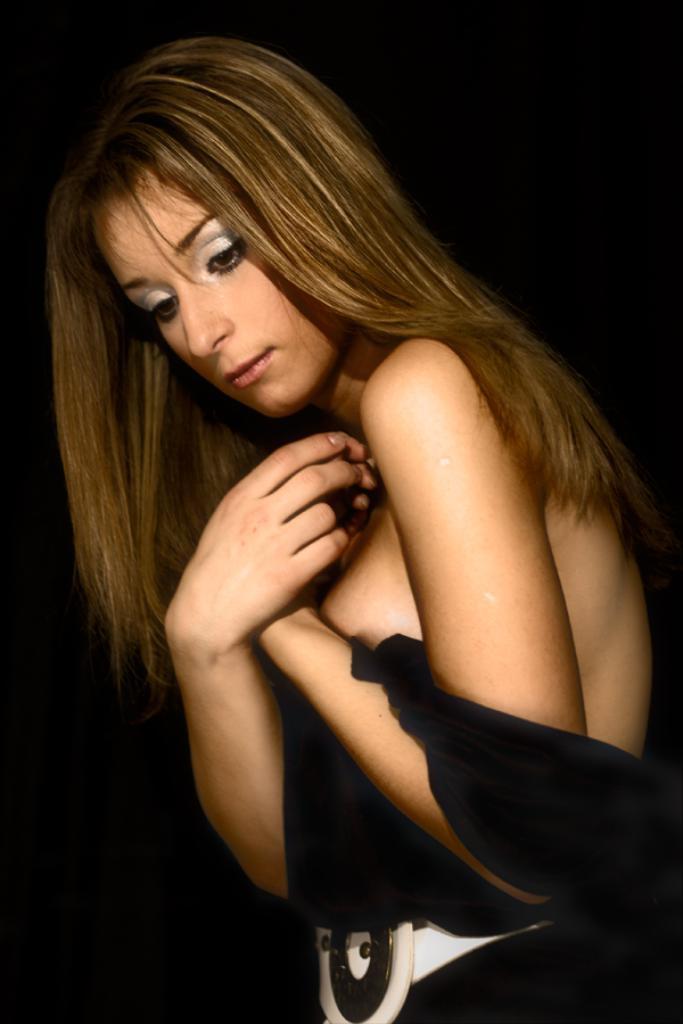Could you give a brief overview of what you see in this image? In this image in the foreground there is one woman. 